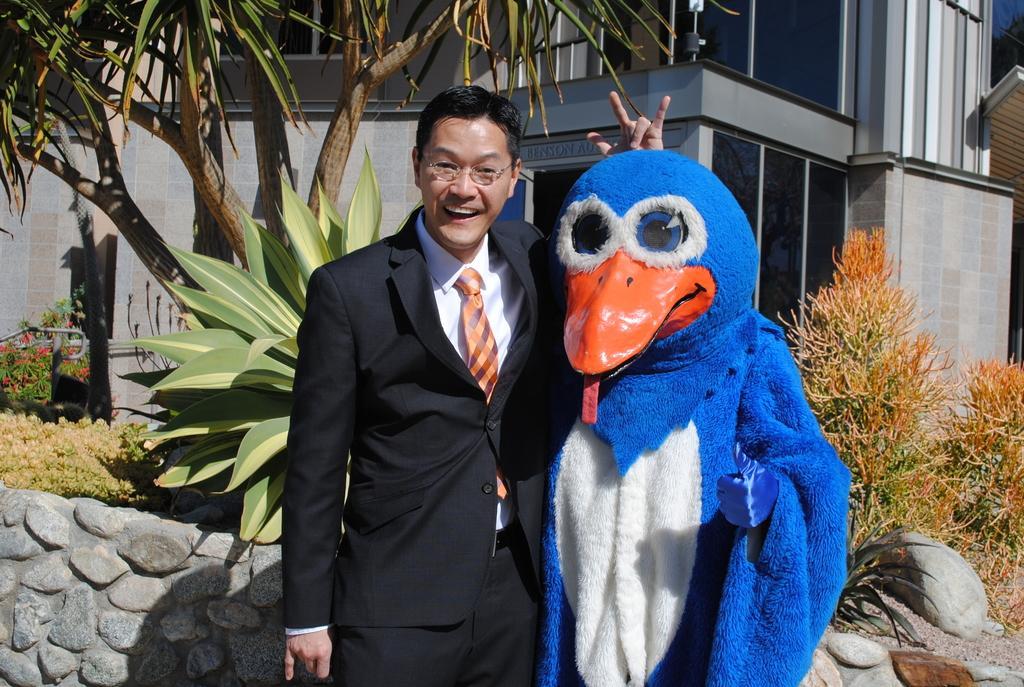In one or two sentences, can you explain what this image depicts? This image is clicked outside. There is a person in the middle. There is another person who is wearing a mask. There are trees behind them, there is a building behind them. 